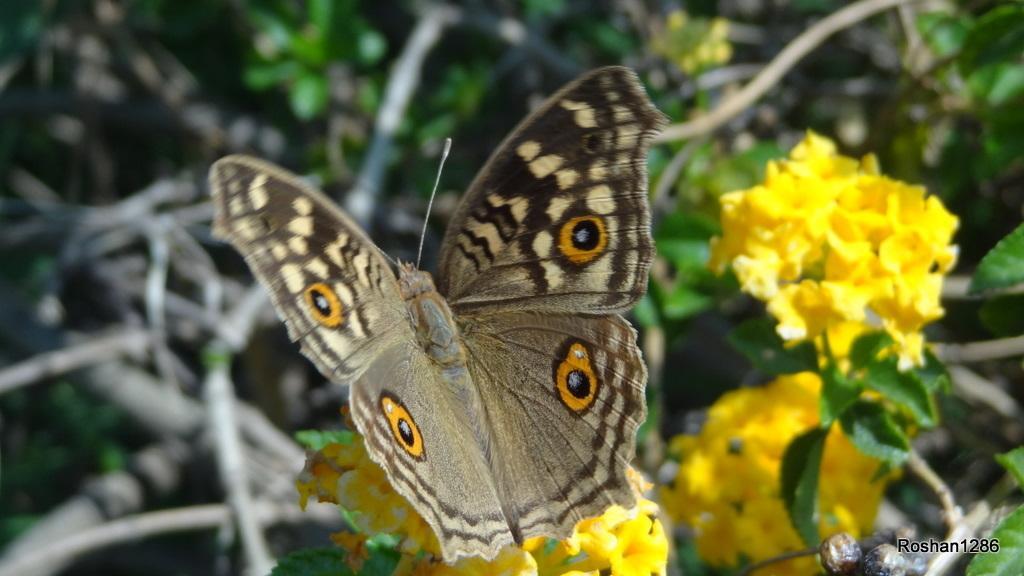Please provide a concise description of this image. In this picture there is a butterfly on yellow color flowers and there are few other flowers beside it and there is something written in the right bottom corner. 